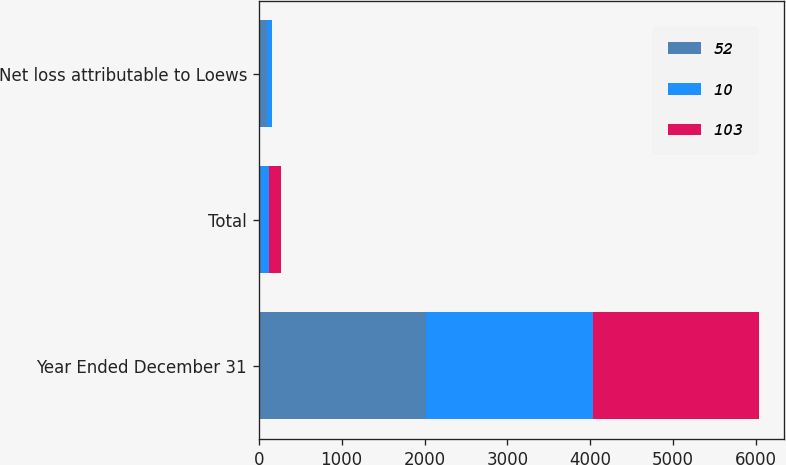Convert chart to OTSL. <chart><loc_0><loc_0><loc_500><loc_500><stacked_bar_chart><ecel><fcel>Year Ended December 31<fcel>Total<fcel>Net loss attributable to Loews<nl><fcel>52<fcel>2015<fcel>28<fcel>103<nl><fcel>10<fcel>2014<fcel>97<fcel>52<nl><fcel>103<fcel>2013<fcel>143<fcel>10<nl></chart> 